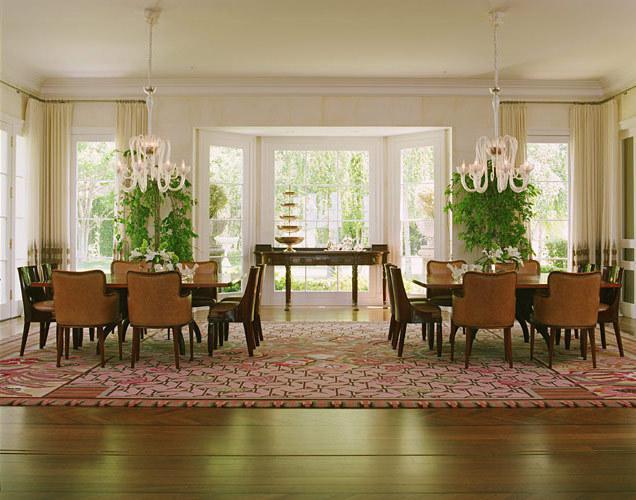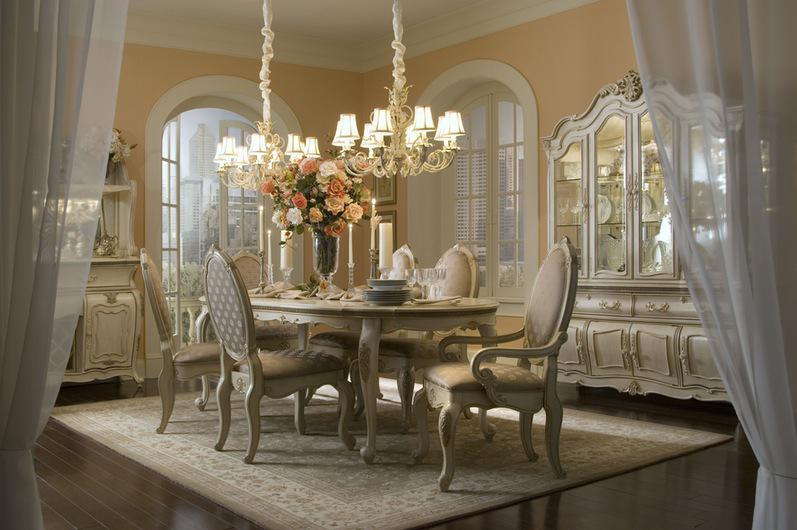The first image is the image on the left, the second image is the image on the right. For the images shown, is this caption "In at least one image there are two parallel kitchen table sets with at least one painting behind them" true? Answer yes or no. No. The first image is the image on the left, the second image is the image on the right. Assess this claim about the two images: "The right image shows two chandleliers suspended over a single table, and six chairs with curved legs are positioned by the table.". Correct or not? Answer yes or no. Yes. 